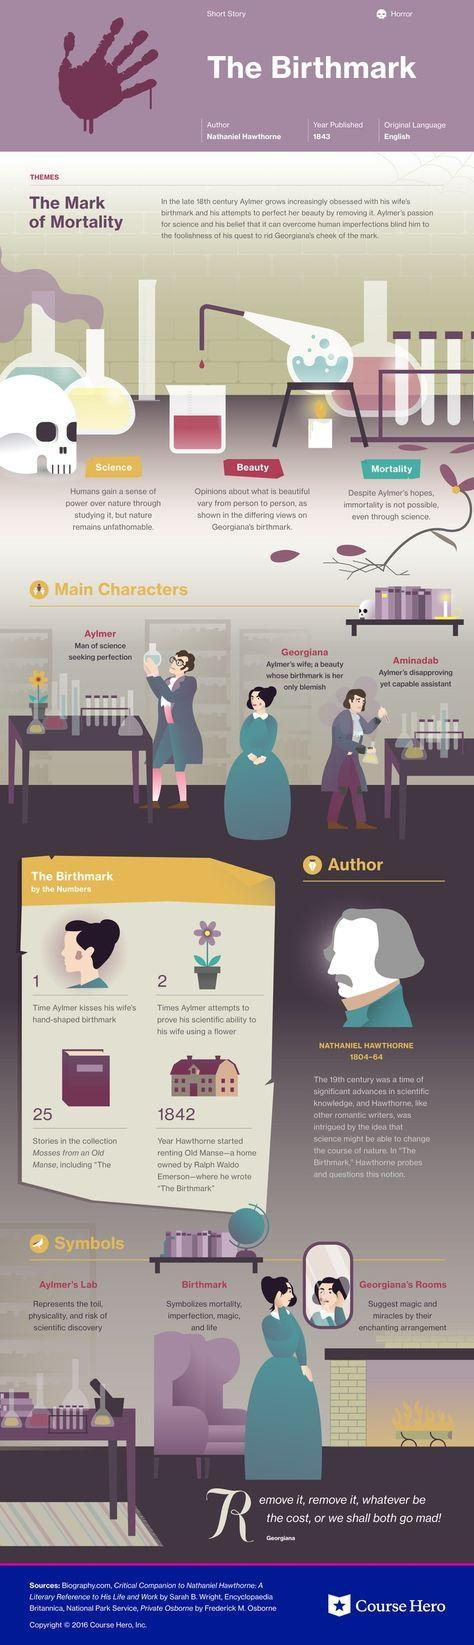What topics does Nathaniel Hawthrone's book "The Mark of Mortality" deal with?
Answer the question with a short phrase. Science, Beauty, Mortality Who is the main protagonist of this fiction, Georgiana, Aminadab, or Aylmer? Aylmer 